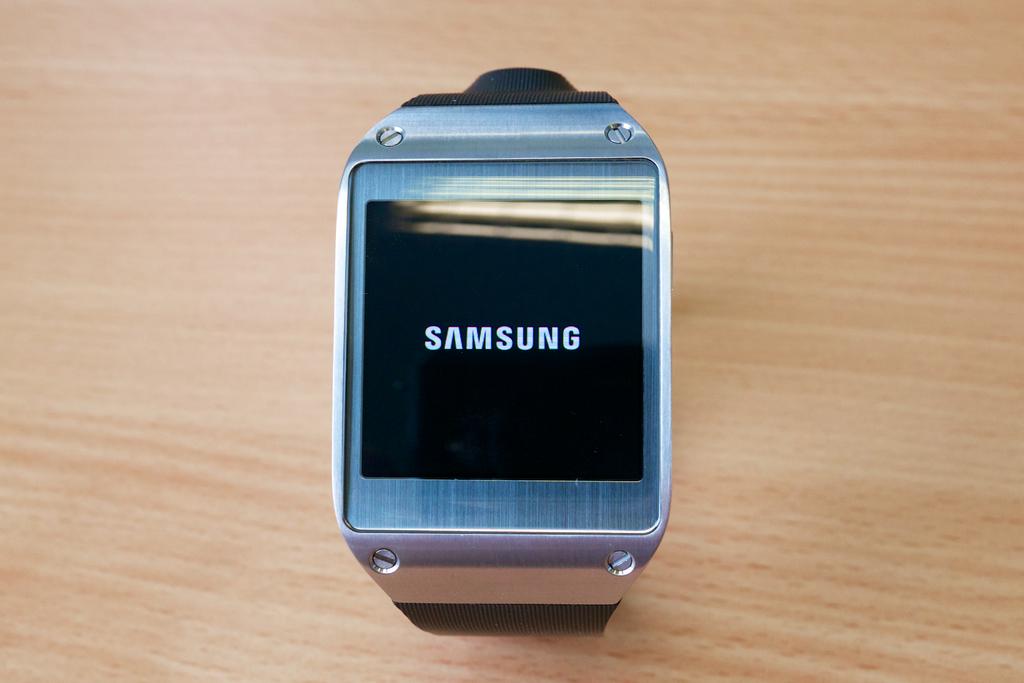What is the brand of watch?
Offer a very short reply. Samsung. What color is the watch band?
Give a very brief answer. Black. 